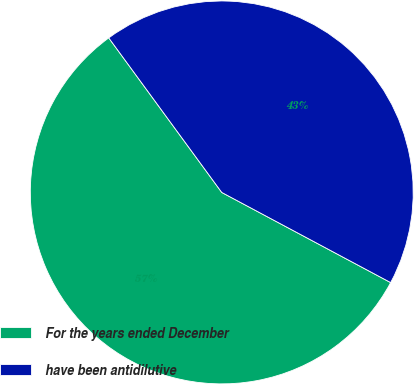<chart> <loc_0><loc_0><loc_500><loc_500><pie_chart><fcel>For the years ended December<fcel>have been antidilutive<nl><fcel>57.15%<fcel>42.85%<nl></chart> 